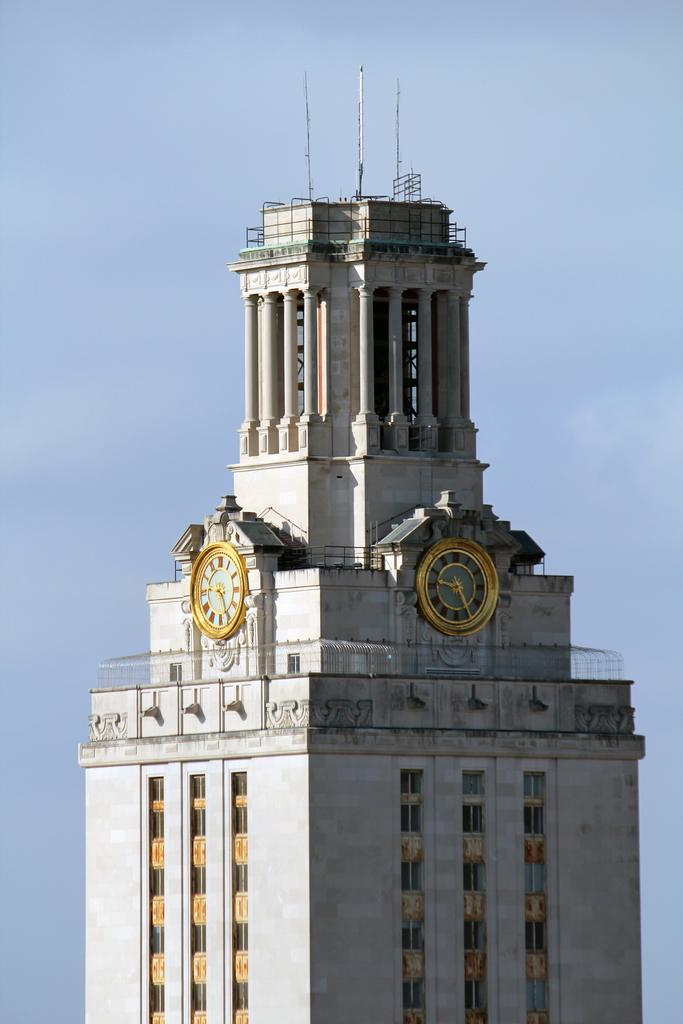What is the main structure in the center of the image? There is a clock tower in the center of the image. What can be seen in the background of the image? Sky is visible in the background of the image. How many sticks are used to create the border of the clock tower in the image? There are no sticks present in the image, and the clock tower does not have a border made of sticks. 